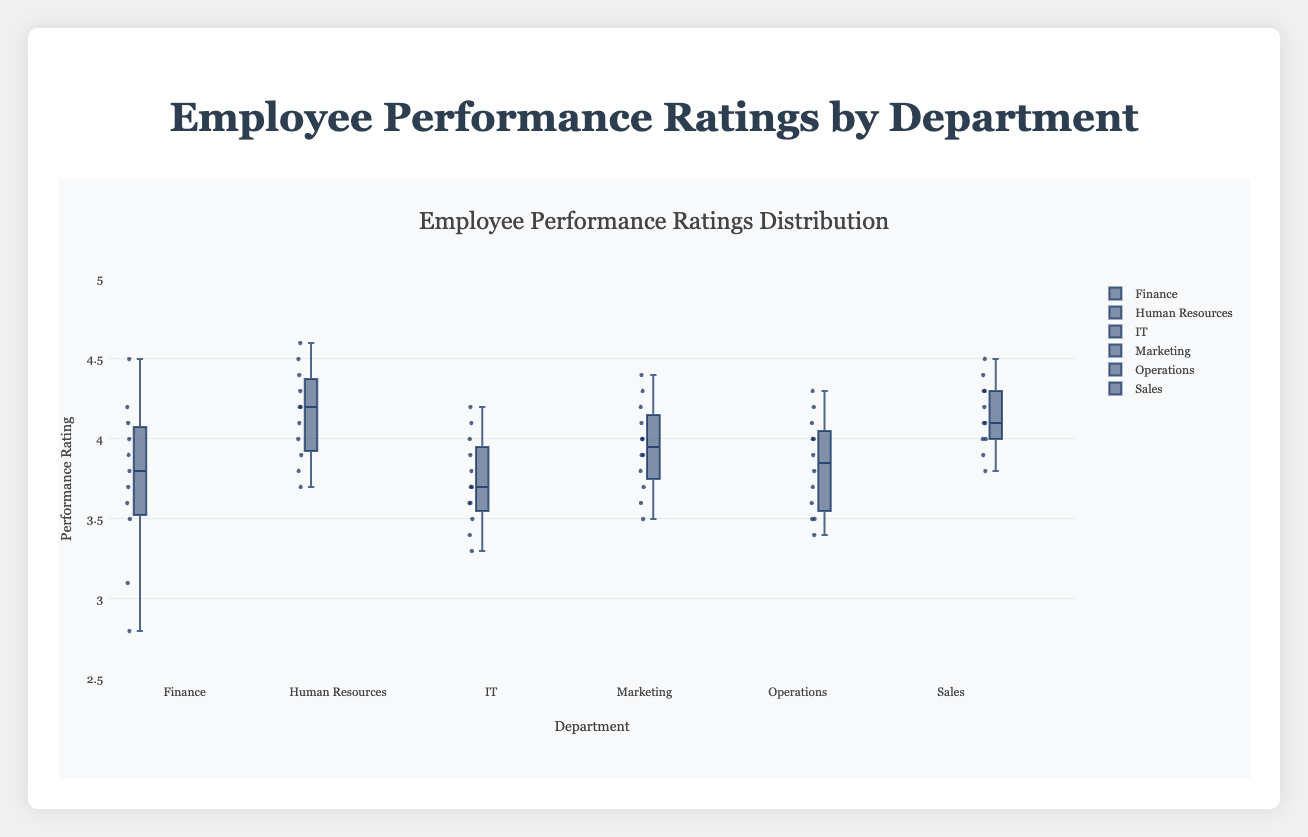What is the median performance rating in the Finance department? The box plot's central line within the Finance department's box represents the median, which typically can be read directly from the plot.
Answer: 3.8 What is the range of performance ratings in the IT department? The range is the difference between the maximum and minimum values in the IT department. These values can be read from the ends of the whiskers in the box plot.
Answer: 3.3 to 4.2 Which department has the highest median performance rating? Compare the central lines of each department's box plot to determine which is the highest.
Answer: Human Resources Between Finance and Sales, which department has a wider interquartile range (IQR)? The IQR is the box's height. Compare the height of the boxes for the Finance and Sales departments.
Answer: Finance Are there any outliers in the Marketing department? Outliers are typically represented by individual points outside the whiskers of the box plot.
Answer: No Which department has the lowest maximum performance rating? Compare the top ends of the whiskers across all departments to identify the lowest maximum rating.
Answer: IT What is the approximate performance rating range covered by the boxes' lower hinges (Q1) and upper hinges (Q3) across all departments? Examine the lower and upper edges of each box to identify the Q1 and Q3 values for each department and compare them.
Answer: 3.4 to 4.5 How does the variability in performance ratings for Human Resources compare to the Operations department? Assess the spread of the data within each department by examining the whiskers and the size of the boxes.
Answer: Human Resources shows less variability than Operations 